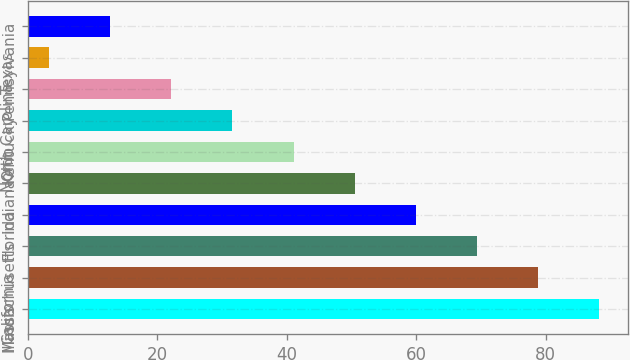Convert chart to OTSL. <chart><loc_0><loc_0><loc_500><loc_500><bar_chart><fcel>Illinois<fcel>California<fcel>Massachusetts<fcel>Florida<fcel>Indiana<fcel>Ohio<fcel>Kentucky<fcel>North Carolina<fcel>Texas<fcel>Pennsylvania<nl><fcel>88.26<fcel>78.82<fcel>69.38<fcel>59.94<fcel>50.5<fcel>41.06<fcel>31.62<fcel>22.18<fcel>3.3<fcel>12.74<nl></chart> 